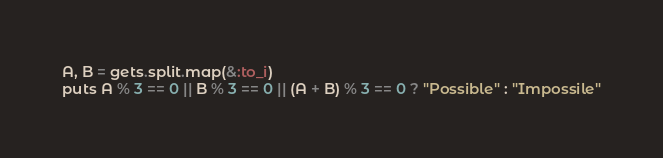Convert code to text. <code><loc_0><loc_0><loc_500><loc_500><_Ruby_>A, B = gets.split.map(&:to_i)
puts A % 3 == 0 || B % 3 == 0 || (A + B) % 3 == 0 ? "Possible" : "Impossile"
</code> 